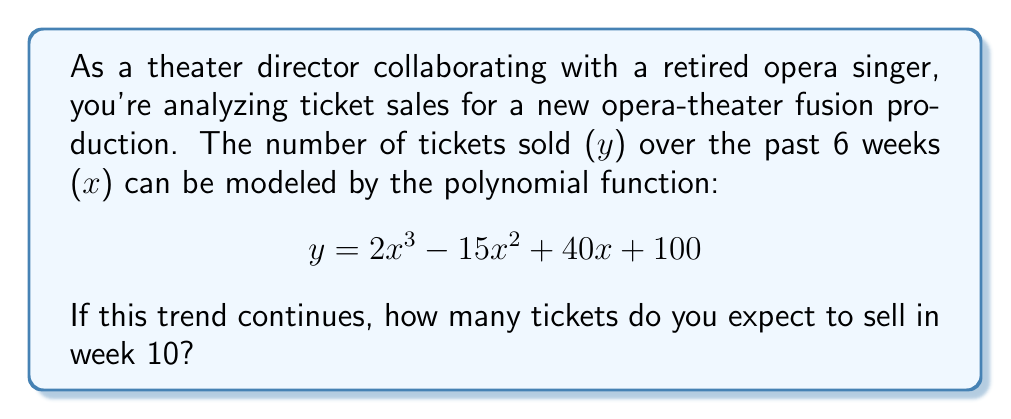Provide a solution to this math problem. To solve this problem, we need to evaluate the given polynomial function at $x = 10$. Let's break it down step-by-step:

1) The polynomial function is:
   $$y = 2x^3 - 15x^2 + 40x + 100$$

2) We need to substitute $x = 10$ into this equation:
   $$y = 2(10)^3 - 15(10)^2 + 40(10) + 100$$

3) Let's evaluate each term:
   - $2(10)^3 = 2(1000) = 2000$
   - $15(10)^2 = 15(100) = 1500$
   - $40(10) = 400$
   - The constant term is already 100

4) Now, let's substitute these values back into the equation:
   $$y = 2000 - 1500 + 400 + 100$$

5) Finally, we can perform the arithmetic:
   $$y = 1000$$

Therefore, if the trend continues, you can expect to sell 1000 tickets in week 10.
Answer: 1000 tickets 